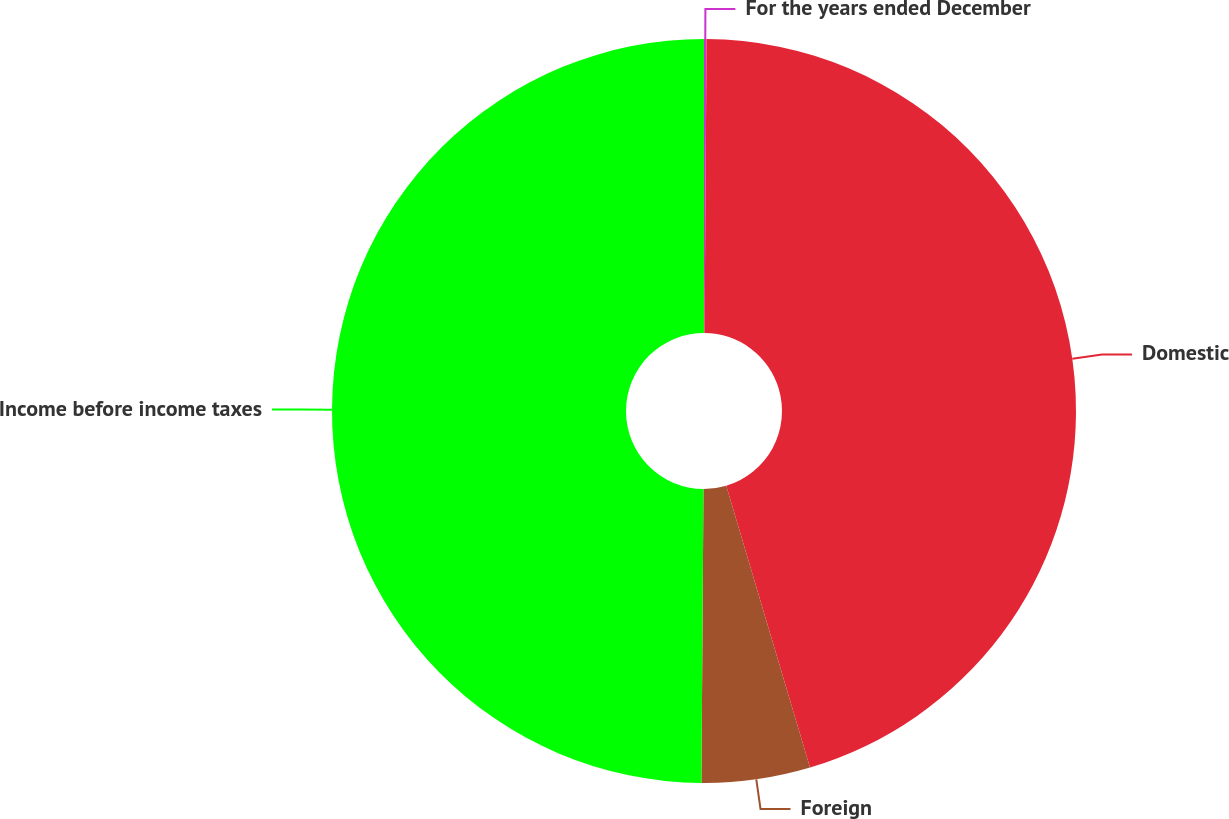Convert chart. <chart><loc_0><loc_0><loc_500><loc_500><pie_chart><fcel>For the years ended December<fcel>Domestic<fcel>Foreign<fcel>Income before income taxes<nl><fcel>0.11%<fcel>45.29%<fcel>4.71%<fcel>49.89%<nl></chart> 